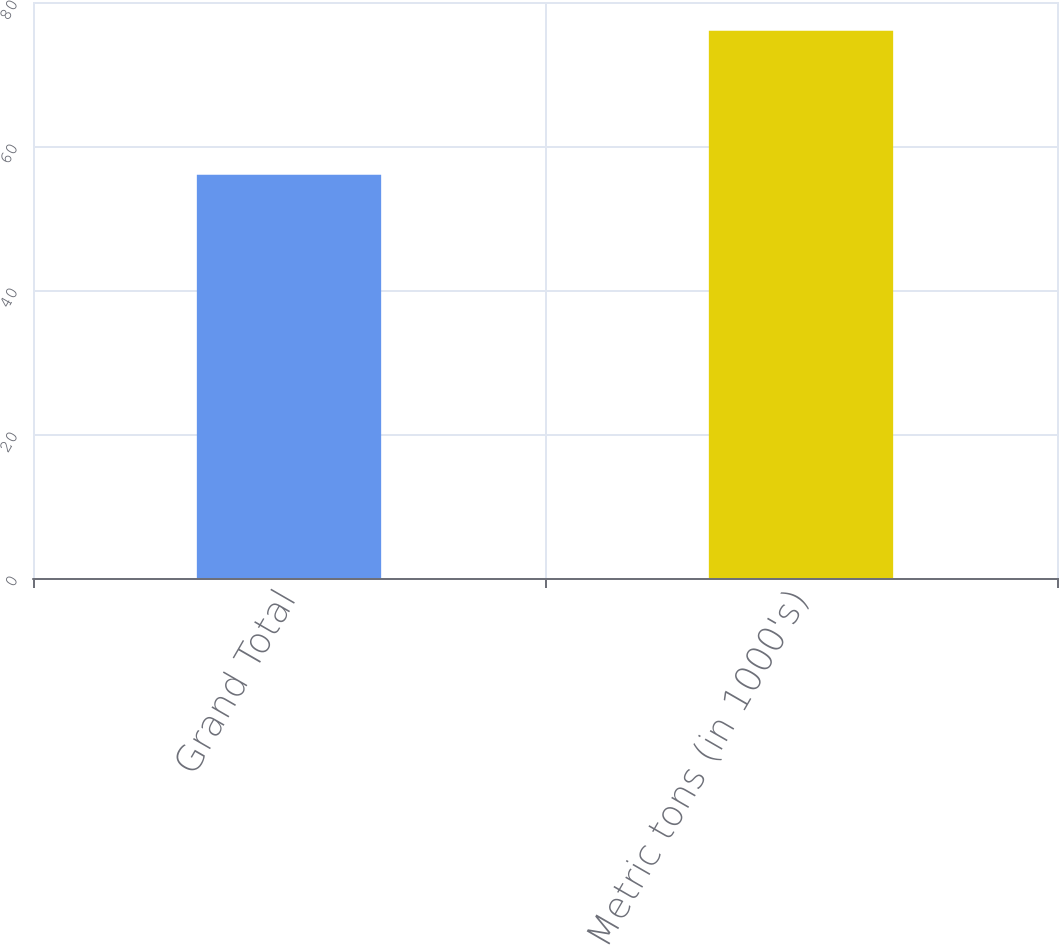Convert chart to OTSL. <chart><loc_0><loc_0><loc_500><loc_500><bar_chart><fcel>Grand Total<fcel>Metric tons (in 1000's)<nl><fcel>56<fcel>76<nl></chart> 